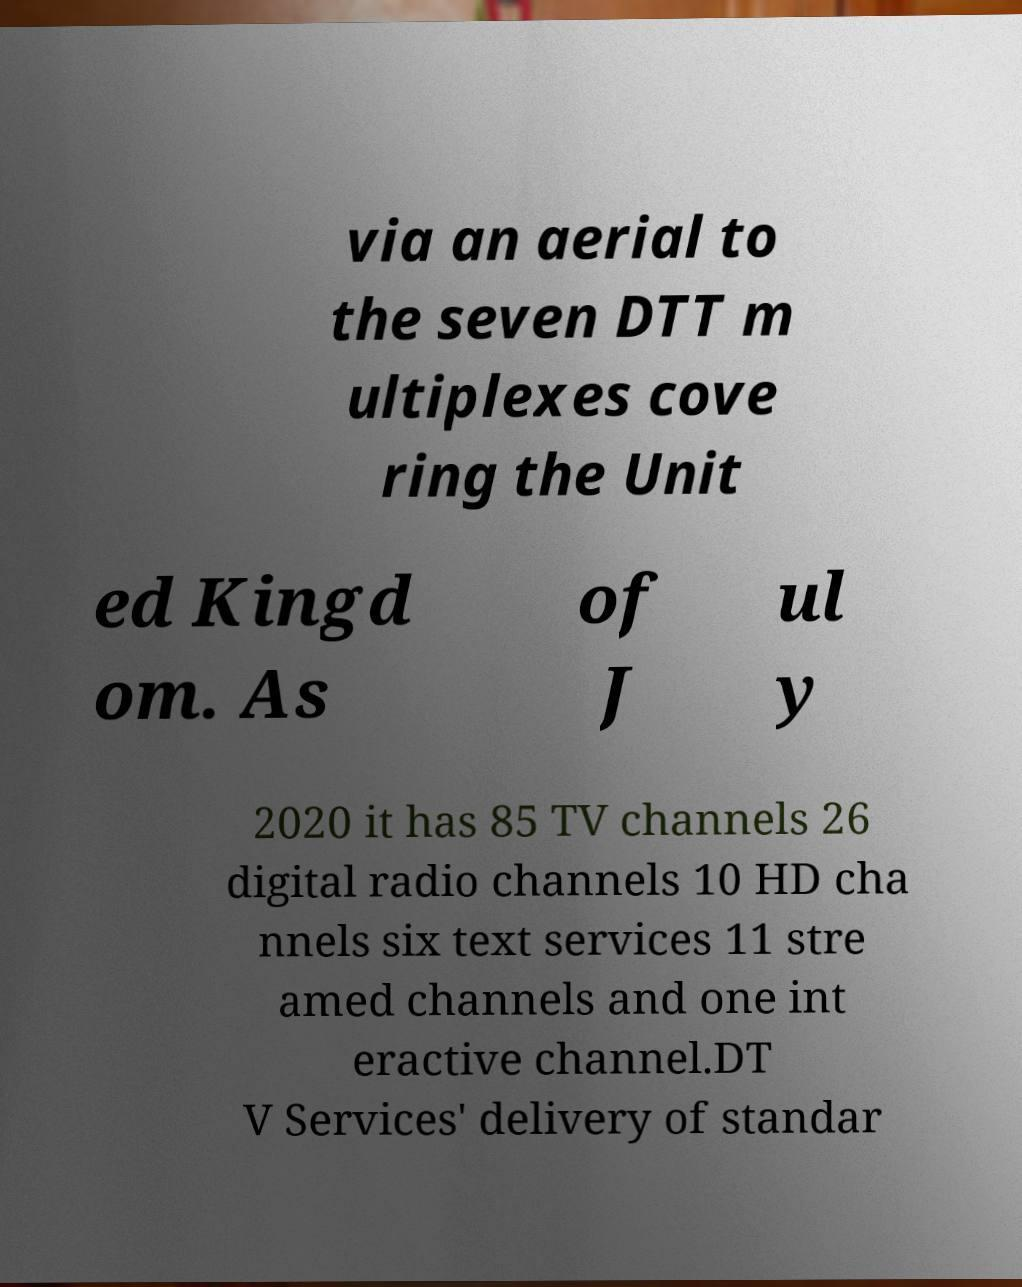Please read and relay the text visible in this image. What does it say? via an aerial to the seven DTT m ultiplexes cove ring the Unit ed Kingd om. As of J ul y 2020 it has 85 TV channels 26 digital radio channels 10 HD cha nnels six text services 11 stre amed channels and one int eractive channel.DT V Services' delivery of standar 